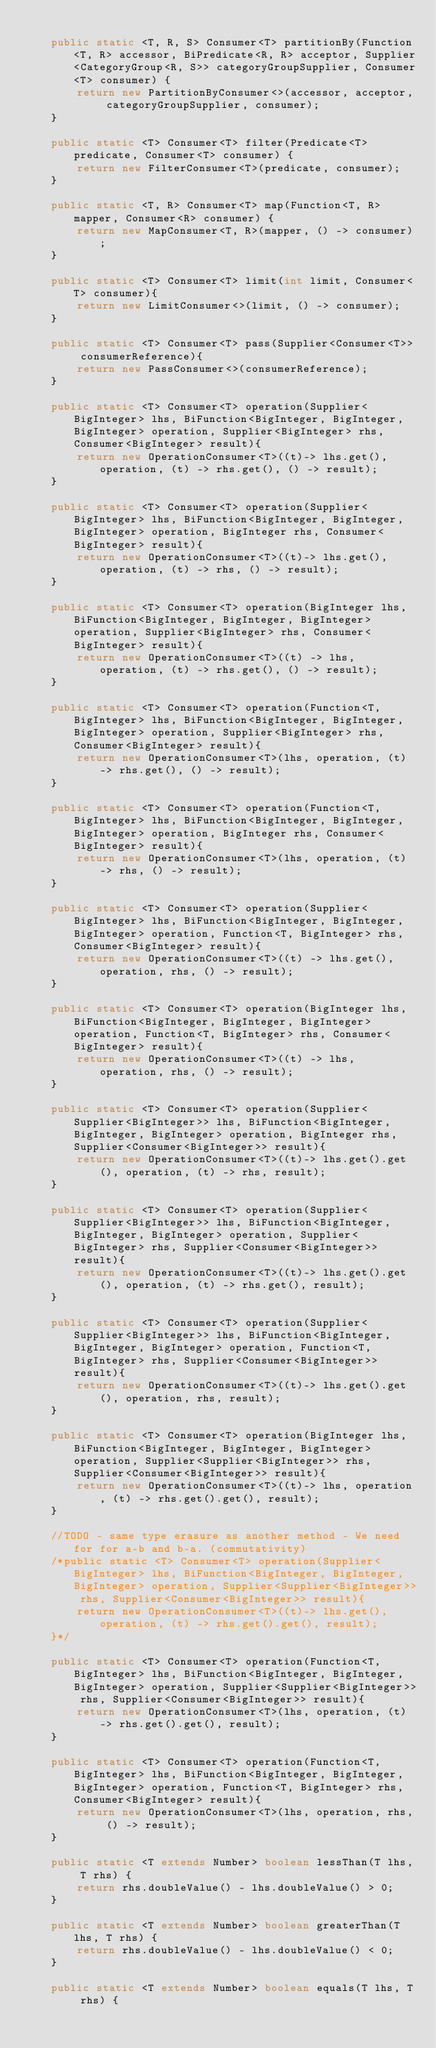<code> <loc_0><loc_0><loc_500><loc_500><_Java_>
    public static <T, R, S> Consumer<T> partitionBy(Function<T, R> accessor, BiPredicate<R, R> acceptor, Supplier<CategoryGroup<R, S>> categoryGroupSupplier, Consumer<T> consumer) {
        return new PartitionByConsumer<>(accessor, acceptor, categoryGroupSupplier, consumer);
    }

    public static <T> Consumer<T> filter(Predicate<T> predicate, Consumer<T> consumer) {
        return new FilterConsumer<T>(predicate, consumer);
    }

    public static <T, R> Consumer<T> map(Function<T, R> mapper, Consumer<R> consumer) {
        return new MapConsumer<T, R>(mapper, () -> consumer);
    }

    public static <T> Consumer<T> limit(int limit, Consumer<T> consumer){
        return new LimitConsumer<>(limit, () -> consumer);
    }

    public static <T> Consumer<T> pass(Supplier<Consumer<T>> consumerReference){
        return new PassConsumer<>(consumerReference);
    }

    public static <T> Consumer<T> operation(Supplier<BigInteger> lhs, BiFunction<BigInteger, BigInteger, BigInteger> operation, Supplier<BigInteger> rhs, Consumer<BigInteger> result){
        return new OperationConsumer<T>((t)-> lhs.get(), operation, (t) -> rhs.get(), () -> result);
    }

    public static <T> Consumer<T> operation(Supplier<BigInteger> lhs, BiFunction<BigInteger, BigInteger, BigInteger> operation, BigInteger rhs, Consumer<BigInteger> result){
        return new OperationConsumer<T>((t)-> lhs.get(), operation, (t) -> rhs, () -> result);
    }

    public static <T> Consumer<T> operation(BigInteger lhs, BiFunction<BigInteger, BigInteger, BigInteger> operation, Supplier<BigInteger> rhs, Consumer<BigInteger> result){
        return new OperationConsumer<T>((t) -> lhs, operation, (t) -> rhs.get(), () -> result);
    }

    public static <T> Consumer<T> operation(Function<T, BigInteger> lhs, BiFunction<BigInteger, BigInteger, BigInteger> operation, Supplier<BigInteger> rhs, Consumer<BigInteger> result){
        return new OperationConsumer<T>(lhs, operation, (t) -> rhs.get(), () -> result);
    }

    public static <T> Consumer<T> operation(Function<T, BigInteger> lhs, BiFunction<BigInteger, BigInteger, BigInteger> operation, BigInteger rhs, Consumer<BigInteger> result){
        return new OperationConsumer<T>(lhs, operation, (t) -> rhs, () -> result);
    }

    public static <T> Consumer<T> operation(Supplier<BigInteger> lhs, BiFunction<BigInteger, BigInteger, BigInteger> operation, Function<T, BigInteger> rhs, Consumer<BigInteger> result){
        return new OperationConsumer<T>((t) -> lhs.get(), operation, rhs, () -> result);
    }

    public static <T> Consumer<T> operation(BigInteger lhs, BiFunction<BigInteger, BigInteger, BigInteger> operation, Function<T, BigInteger> rhs, Consumer<BigInteger> result){
        return new OperationConsumer<T>((t) -> lhs, operation, rhs, () -> result);
    }

    public static <T> Consumer<T> operation(Supplier<Supplier<BigInteger>> lhs, BiFunction<BigInteger, BigInteger, BigInteger> operation, BigInteger rhs, Supplier<Consumer<BigInteger>> result){
        return new OperationConsumer<T>((t)-> lhs.get().get(), operation, (t) -> rhs, result);
    }

    public static <T> Consumer<T> operation(Supplier<Supplier<BigInteger>> lhs, BiFunction<BigInteger, BigInteger, BigInteger> operation, Supplier<BigInteger> rhs, Supplier<Consumer<BigInteger>> result){
        return new OperationConsumer<T>((t)-> lhs.get().get(), operation, (t) -> rhs.get(), result);
    }

    public static <T> Consumer<T> operation(Supplier<Supplier<BigInteger>> lhs, BiFunction<BigInteger, BigInteger, BigInteger> operation, Function<T, BigInteger> rhs, Supplier<Consumer<BigInteger>> result){
        return new OperationConsumer<T>((t)-> lhs.get().get(), operation, rhs, result);
    }

    public static <T> Consumer<T> operation(BigInteger lhs, BiFunction<BigInteger, BigInteger, BigInteger> operation, Supplier<Supplier<BigInteger>> rhs, Supplier<Consumer<BigInteger>> result){
        return new OperationConsumer<T>((t)-> lhs, operation, (t) -> rhs.get().get(), result);
    }

    //TODO - same type erasure as another method - We need for for a-b and b-a. (commutativity)
    /*public static <T> Consumer<T> operation(Supplier<BigInteger> lhs, BiFunction<BigInteger, BigInteger, BigInteger> operation, Supplier<Supplier<BigInteger>> rhs, Supplier<Consumer<BigInteger>> result){
        return new OperationConsumer<T>((t)-> lhs.get(), operation, (t) -> rhs.get().get(), result);
    }*/

    public static <T> Consumer<T> operation(Function<T, BigInteger> lhs, BiFunction<BigInteger, BigInteger, BigInteger> operation, Supplier<Supplier<BigInteger>> rhs, Supplier<Consumer<BigInteger>> result){
        return new OperationConsumer<T>(lhs, operation, (t) -> rhs.get().get(), result);
    }

    public static <T> Consumer<T> operation(Function<T, BigInteger> lhs, BiFunction<BigInteger, BigInteger, BigInteger> operation, Function<T, BigInteger> rhs, Consumer<BigInteger> result){
        return new OperationConsumer<T>(lhs, operation, rhs, () -> result);
    }

    public static <T extends Number> boolean lessThan(T lhs, T rhs) {
        return rhs.doubleValue() - lhs.doubleValue() > 0;
    }

    public static <T extends Number> boolean greaterThan(T lhs, T rhs) {
        return rhs.doubleValue() - lhs.doubleValue() < 0;
    }

    public static <T extends Number> boolean equals(T lhs, T rhs) {</code> 